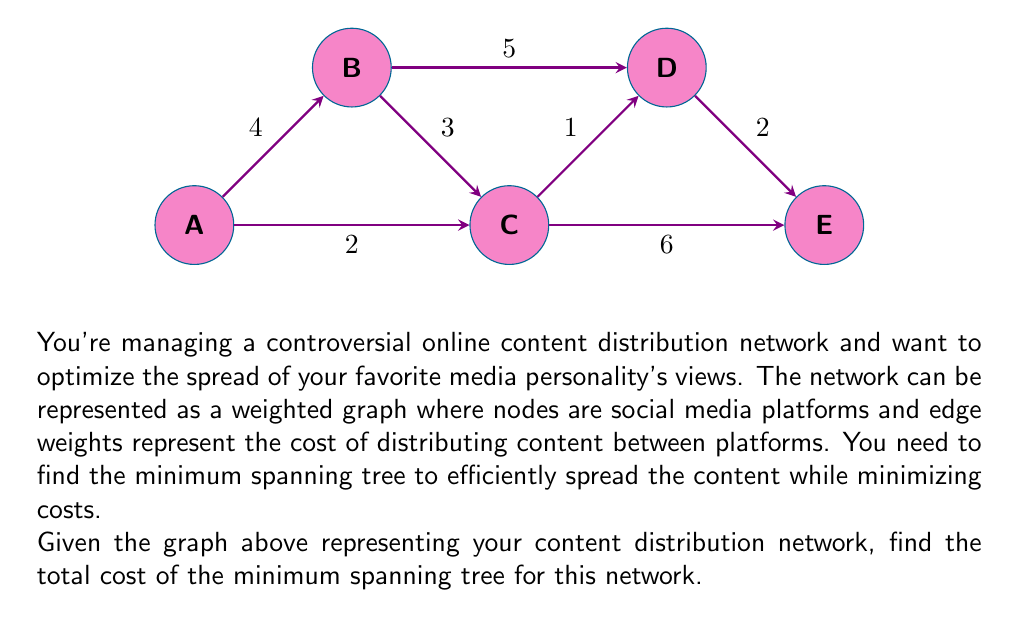Show me your answer to this math problem. To find the minimum spanning tree (MST) of this graph, we'll use Kruskal's algorithm. This algorithm works by sorting all edges by weight and then adding them to the MST if they don't create a cycle, until all nodes are connected.

Step 1: Sort the edges by weight.
1. C-D: 1
2. A-C: 2
3. D-E: 2
4. B-C: 3
5. A-B: 4
6. B-D: 5
7. C-E: 6

Step 2: Add edges to the MST, avoiding cycles.
1. Add C-D (cost: 1)
2. Add A-C (cost: 2)
3. Add D-E (cost: 2)
4. Add B-C (cost: 3)

At this point, all nodes are connected, and we have our MST.

Step 3: Calculate the total cost.
Total cost = 1 + 2 + 2 + 3 = 8

Therefore, the minimum spanning tree has a total cost of 8.
Answer: 8 